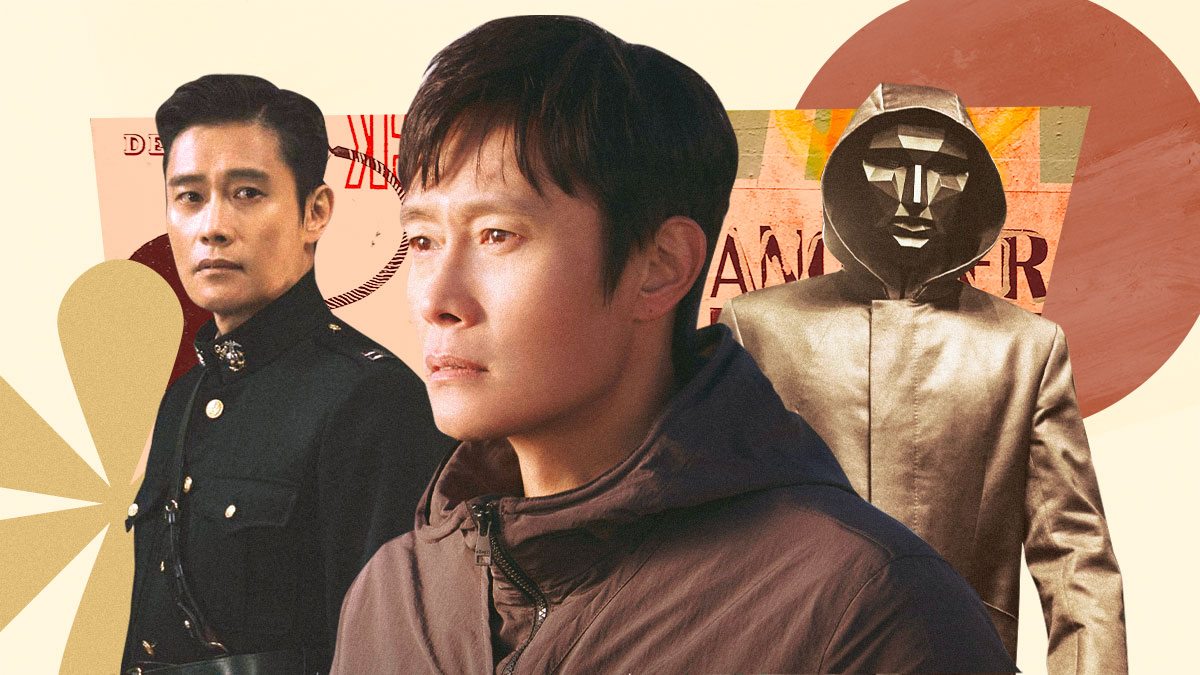What secrets might the character on the right be hiding behind that mask? The character on the right, concealed behind a mask and wearing a gold hooded jacket, might be hiding a multitude of secrets. Given his enigmatic appearance, he could be involved in clandestine operations or have a hidden identity unknown to those around him. Perhaps he is a vigilante seeking justice outside the bounds of the law, or he might be protecting himself from enemies who seek to uncover his true identity. The mask could also symbolize deeper psychological scars, a way to shield his emotions from the world while he embarks on a mission that requires anonymity and bravery. What if this character was not a person but a symbolic representation of something? If this character were a symbolic representation rather than an actual person, the mask and gold hooded jacket could signify the duality of human nature and the concept of hidden truths. The mask might represent the façade that people put up to navigate societal expectations, concealing their true emotions and intentions. Alternatively, it could symbolize the unknown and the fear of exposing one's vulnerabilities. The gold color of the jacket could represent value and deception, suggesting that what glitters is not always gold and urging a deeper understanding beyond external appearances. 